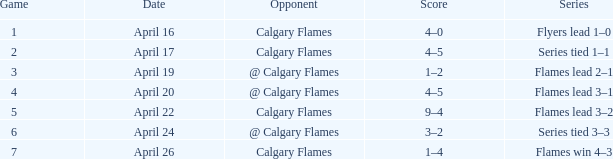Which series possesses a score of 9-4? Flames lead 3–2. 